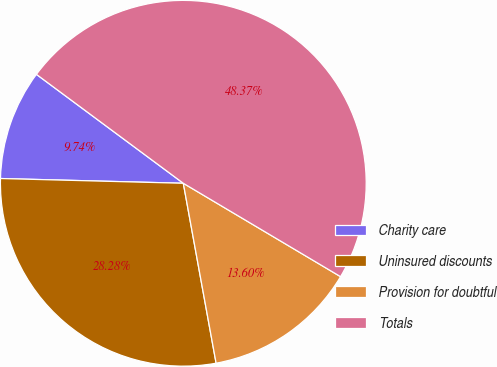Convert chart to OTSL. <chart><loc_0><loc_0><loc_500><loc_500><pie_chart><fcel>Charity care<fcel>Uninsured discounts<fcel>Provision for doubtful<fcel>Totals<nl><fcel>9.74%<fcel>28.28%<fcel>13.6%<fcel>48.37%<nl></chart> 